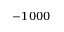Convert formula to latex. <formula><loc_0><loc_0><loc_500><loc_500>- 1 0 0 0</formula> 